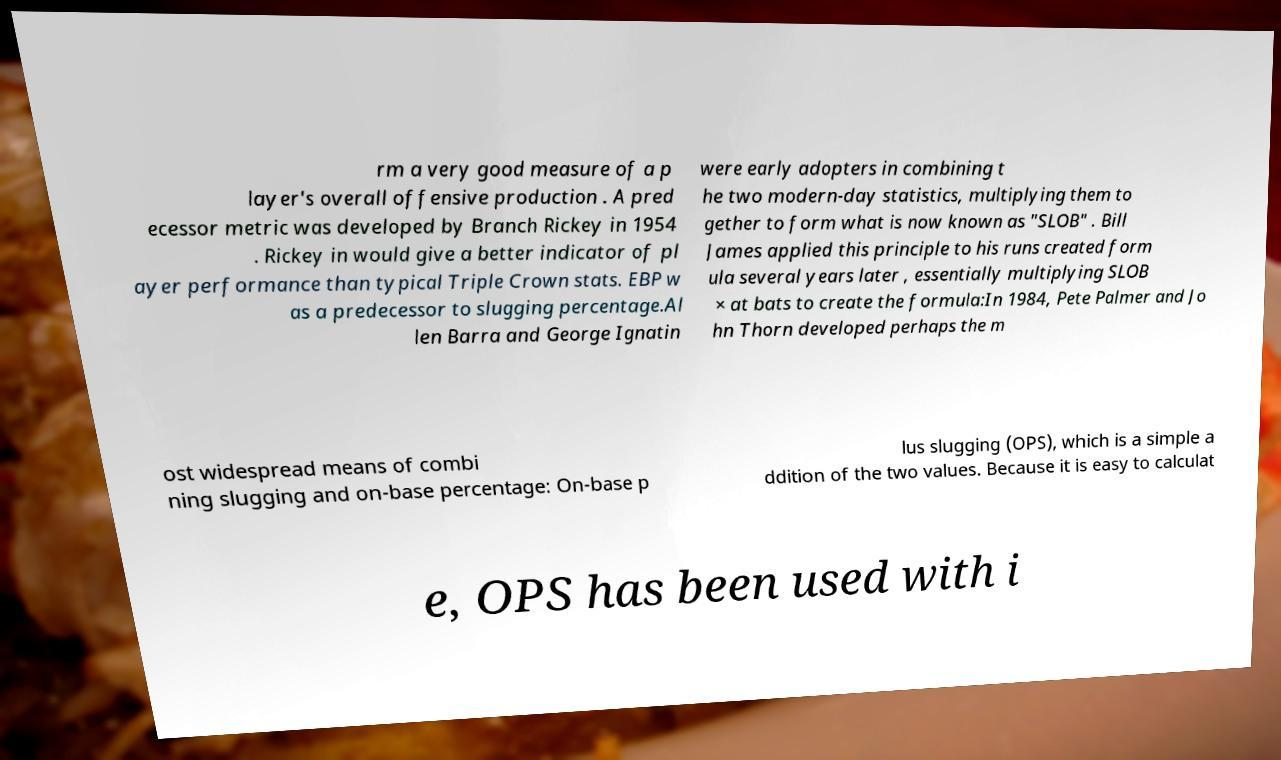For documentation purposes, I need the text within this image transcribed. Could you provide that? rm a very good measure of a p layer's overall offensive production . A pred ecessor metric was developed by Branch Rickey in 1954 . Rickey in would give a better indicator of pl ayer performance than typical Triple Crown stats. EBP w as a predecessor to slugging percentage.Al len Barra and George Ignatin were early adopters in combining t he two modern-day statistics, multiplying them to gether to form what is now known as "SLOB" . Bill James applied this principle to his runs created form ula several years later , essentially multiplying SLOB × at bats to create the formula:In 1984, Pete Palmer and Jo hn Thorn developed perhaps the m ost widespread means of combi ning slugging and on-base percentage: On-base p lus slugging (OPS), which is a simple a ddition of the two values. Because it is easy to calculat e, OPS has been used with i 